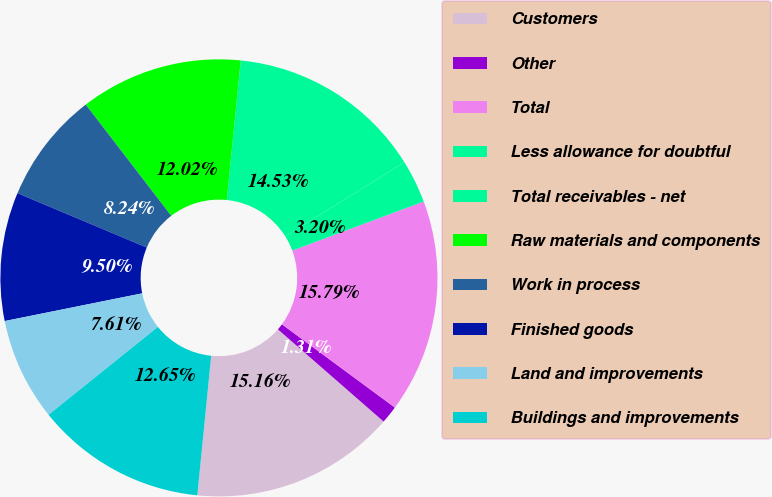Convert chart. <chart><loc_0><loc_0><loc_500><loc_500><pie_chart><fcel>Customers<fcel>Other<fcel>Total<fcel>Less allowance for doubtful<fcel>Total receivables - net<fcel>Raw materials and components<fcel>Work in process<fcel>Finished goods<fcel>Land and improvements<fcel>Buildings and improvements<nl><fcel>15.16%<fcel>1.31%<fcel>15.79%<fcel>3.2%<fcel>14.53%<fcel>12.02%<fcel>8.24%<fcel>9.5%<fcel>7.61%<fcel>12.65%<nl></chart> 